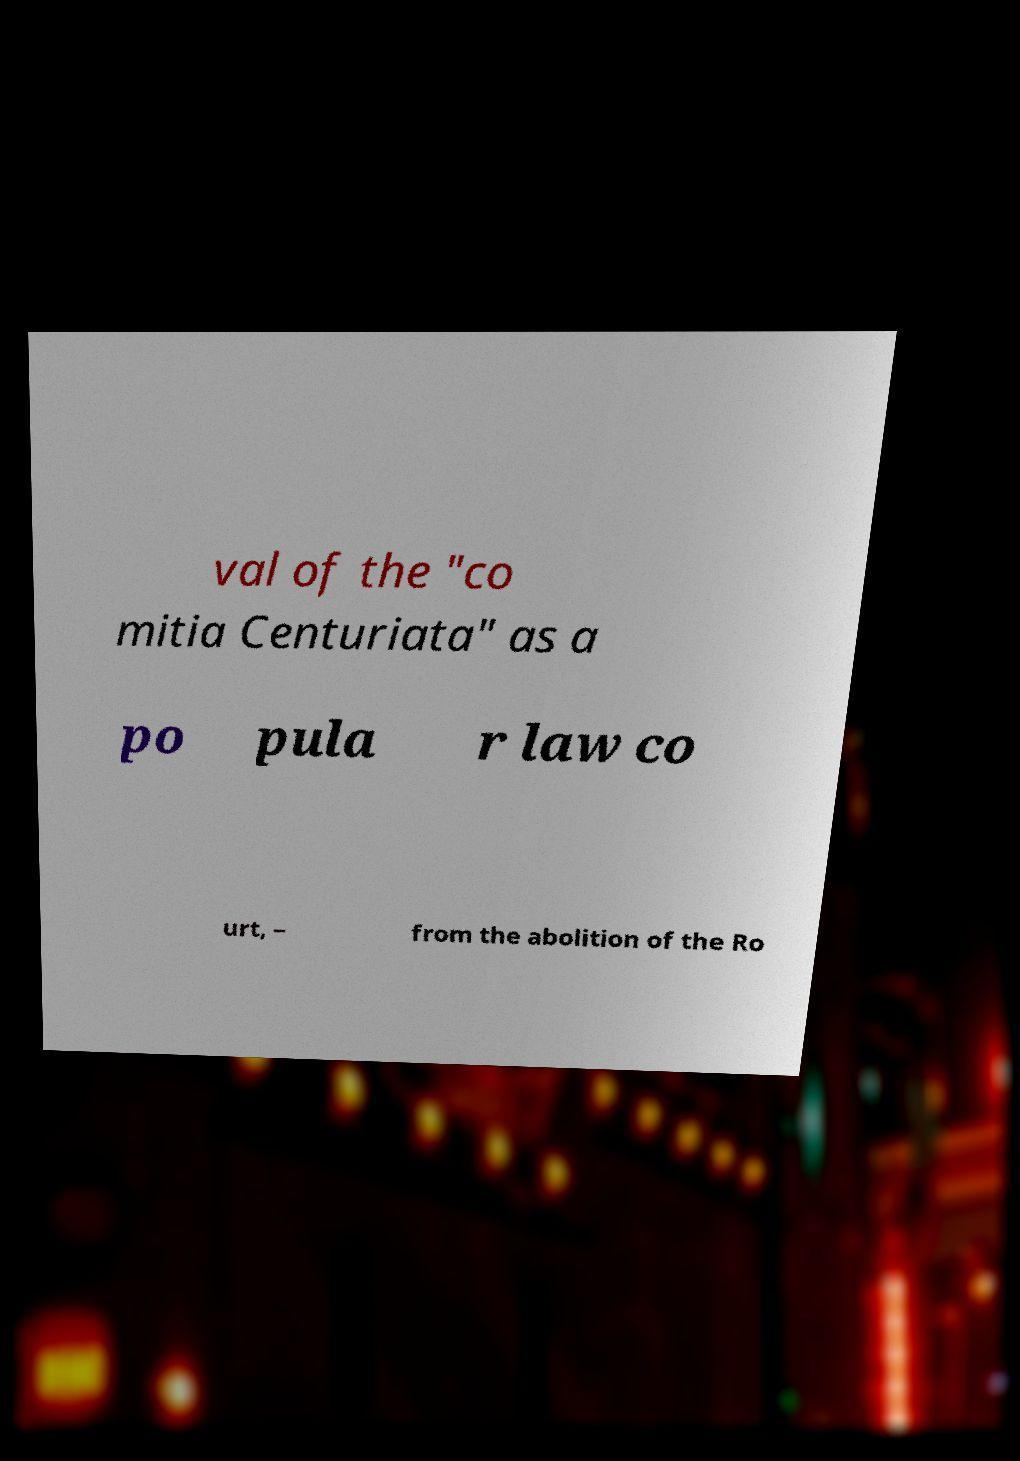I need the written content from this picture converted into text. Can you do that? val of the "co mitia Centuriata" as a po pula r law co urt, – from the abolition of the Ro 